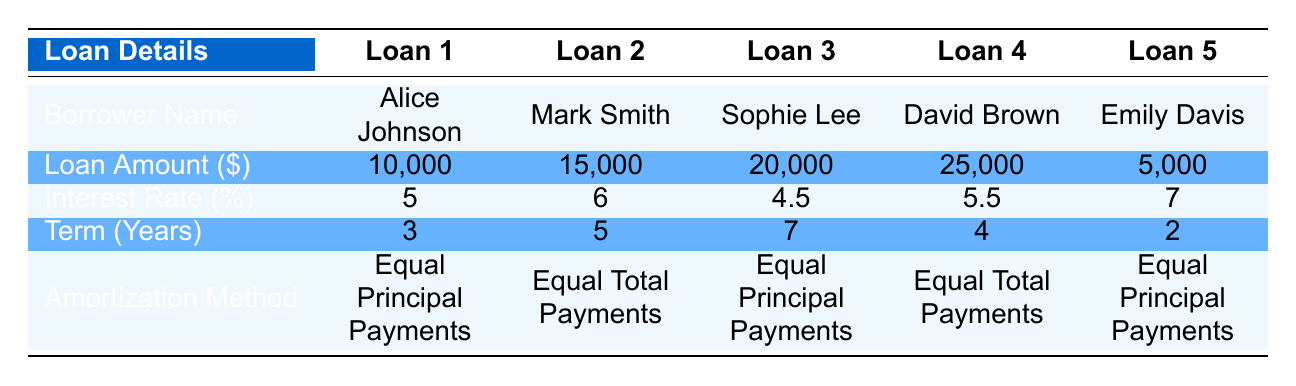What is the total loan amount for all borrowers? The total loan amount is calculated by summing the loan amounts of all borrowers: 10,000 + 15,000 + 20,000 + 25,000 + 5,000 = 75,000.
Answer: 75,000 Which borrower has the highest interest rate? By scanning the interest rates in the table, David Brown has the highest interest rate at 5.5 percent.
Answer: David Brown Is there any borrower with a loan amount less than 10,000? Emily Davis has a loan amount of 5,000, which is less than 10,000.
Answer: Yes What is the average interest rate of all loans? To find the average interest rate, sum the rates: 5 + 6 + 4.5 + 5.5 + 7 = 28, then divide by the number of loans (5): 28 / 5 = 5.6.
Answer: 5.6 Which amortization method is used by the majority of borrowers? By reviewing the table, the "Equal Principal Payments" method is listed for three borrowers (Alice Johnson, Sophie Lee, and Emily Davis), while "Equal Total Payments" is used by two borrowers (Mark Smith and David Brown).
Answer: Equal Principal Payments What is the difference in loan amounts between the largest and smallest loans? The largest loan is 25,000 (David Brown) and the smallest loan is 5,000 (Emily Davis). To find the difference: 25,000 - 5,000 = 20,000.
Answer: 20,000 Are there any loans with a term of 2 years? Yes, Emily Davis has a loan with a term of 2 years.
Answer: Yes How many borrowers have a loan term longer than 5 years? Scanning the term years, only Sophie Lee has a term of 7 years, which is longer than 5 years.
Answer: 1 